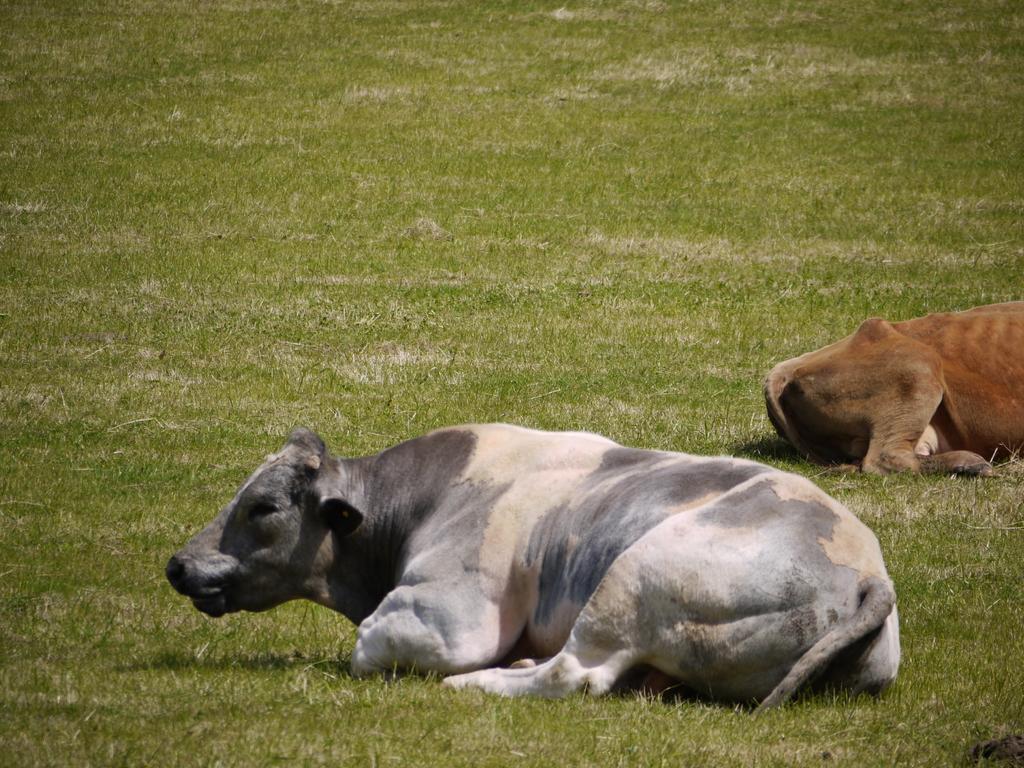Could you give a brief overview of what you see in this image? In the image,there is a cow and another animal laying on the ground. 